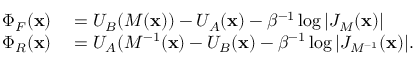<formula> <loc_0><loc_0><loc_500><loc_500>\begin{array} { r l } { \Phi _ { F } ( x ) } & = U _ { B } ( M ( x ) ) - U _ { A } ( x ) - \beta ^ { - 1 } \log { \left | { J _ { M } ( x ) } \right | } } \\ { \Phi _ { R } ( x ) } & = U _ { A } ( M ^ { - 1 } ( x ) - U _ { B } ( x ) - \beta ^ { - 1 } \log { \left | { J _ { M ^ { - 1 } } ( x ) } \right | } . } \end{array}</formula> 